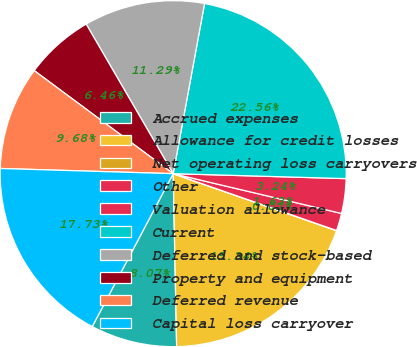<chart> <loc_0><loc_0><loc_500><loc_500><pie_chart><fcel>Accrued expenses<fcel>Allowance for credit losses<fcel>Net operating loss carryovers<fcel>Other<fcel>Valuation allowance<fcel>Current<fcel>Deferred and stock-based<fcel>Property and equipment<fcel>Deferred revenue<fcel>Capital loss carryover<nl><fcel>8.07%<fcel>19.34%<fcel>0.02%<fcel>1.63%<fcel>3.24%<fcel>22.56%<fcel>11.29%<fcel>6.46%<fcel>9.68%<fcel>17.73%<nl></chart> 